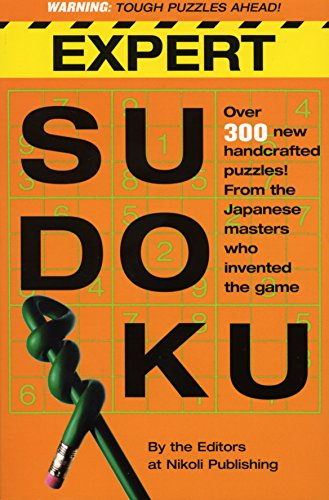Is this book related to Humor & Entertainment? The book 'Expert Sudoku' is not primarily related to Humor & Entertainment; it best fits within the 'Games & Puzzles' genre, focusing on challenging Sudoku puzzles. 